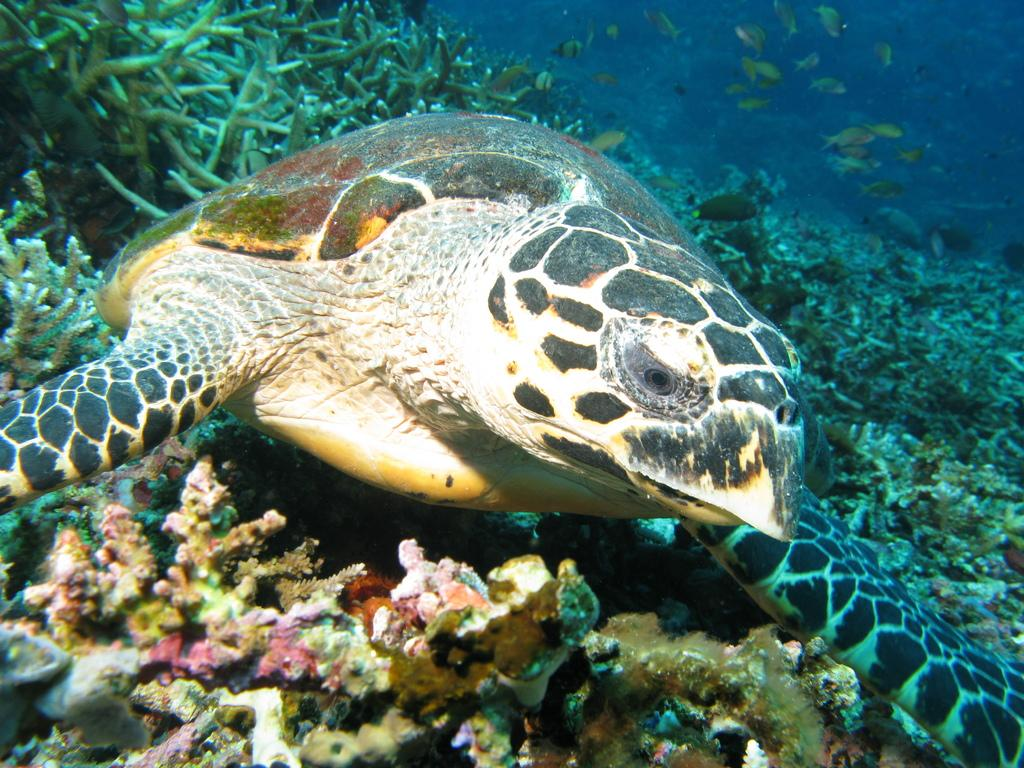What type of animal is in the image? There is a tortoise in the image. Can you describe the color pattern of the tortoise? The tortoise has a white and black color pattern. What type of vegetation is present in the image? There are green color sea plants in the image. What other creatures can be seen in the background of the image? There are multiple fishes visible in the background of the image. What type of letter is the tortoise holding in the image? There is no letter present in the image; the tortoise is not holding anything. 